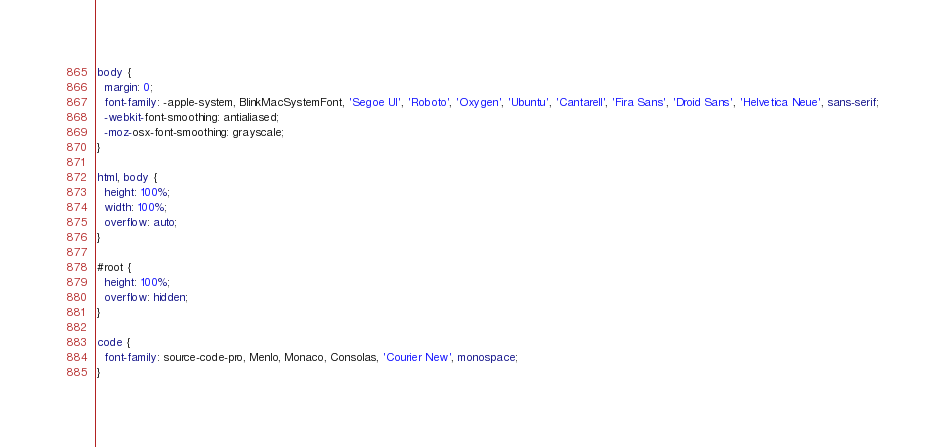Convert code to text. <code><loc_0><loc_0><loc_500><loc_500><_CSS_>body {
  margin: 0;
  font-family: -apple-system, BlinkMacSystemFont, 'Segoe UI', 'Roboto', 'Oxygen', 'Ubuntu', 'Cantarell', 'Fira Sans', 'Droid Sans', 'Helvetica Neue', sans-serif;
  -webkit-font-smoothing: antialiased;
  -moz-osx-font-smoothing: grayscale;
}

html, body {
  height: 100%;
  width: 100%;
  overflow: auto;
}

#root {
  height: 100%;
  overflow: hidden;
}

code {
  font-family: source-code-pro, Menlo, Monaco, Consolas, 'Courier New', monospace;
}</code> 